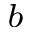Convert formula to latex. <formula><loc_0><loc_0><loc_500><loc_500>^ { b }</formula> 